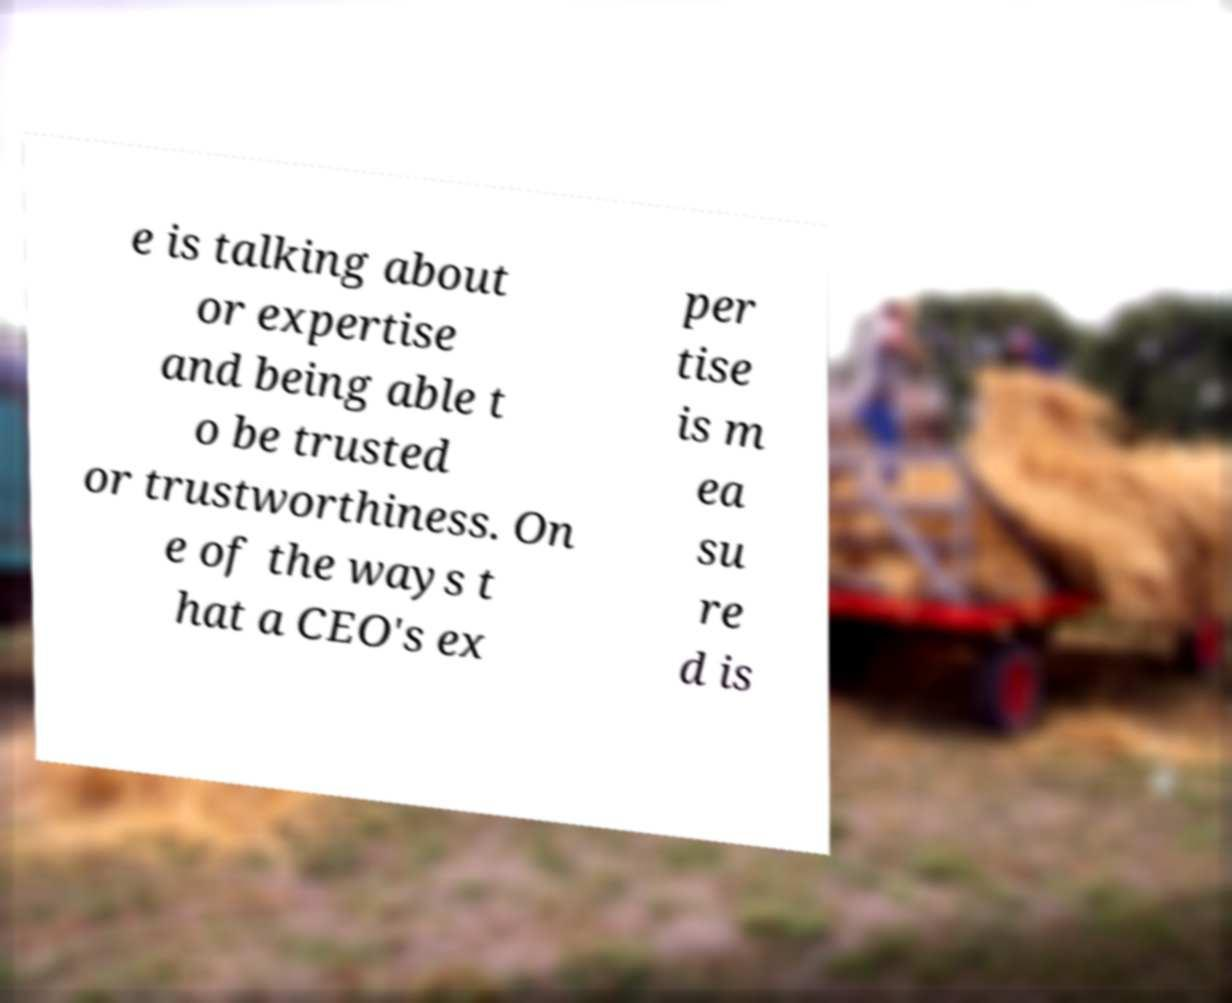I need the written content from this picture converted into text. Can you do that? e is talking about or expertise and being able t o be trusted or trustworthiness. On e of the ways t hat a CEO's ex per tise is m ea su re d is 